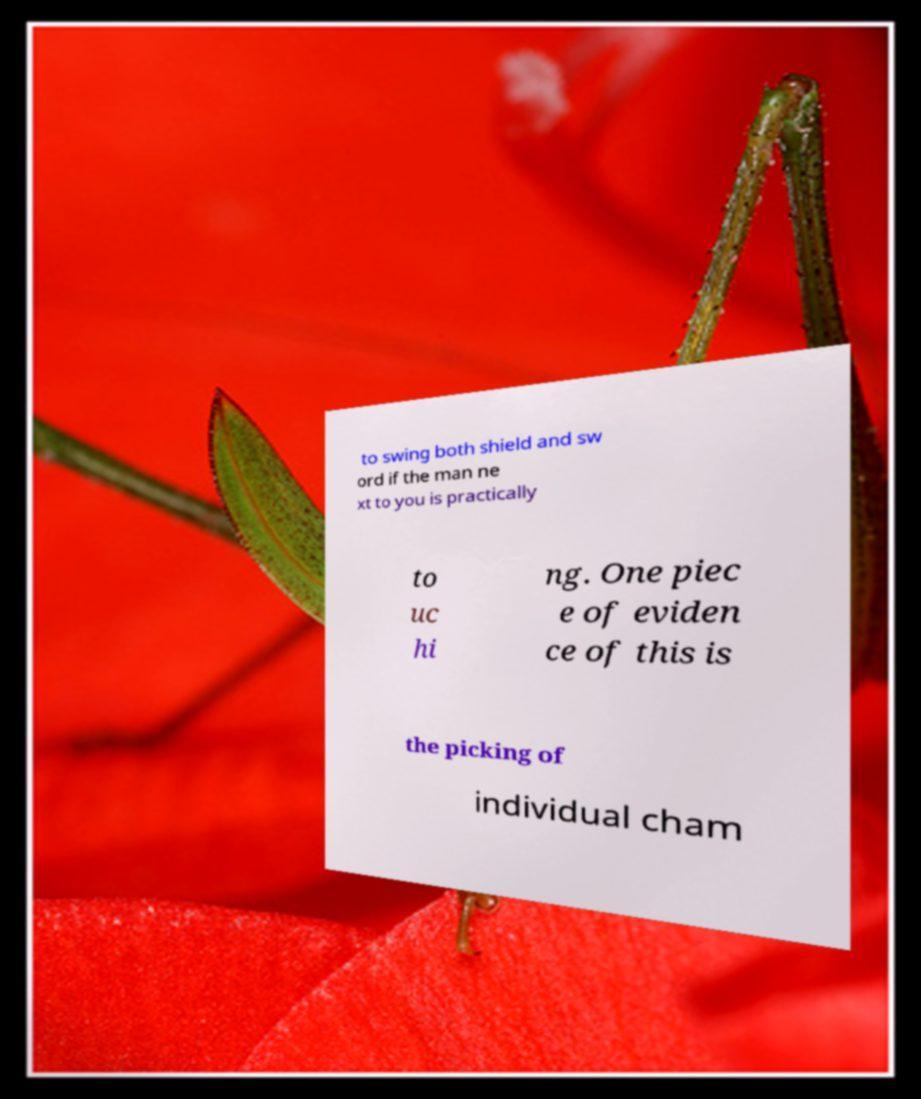What messages or text are displayed in this image? I need them in a readable, typed format. to swing both shield and sw ord if the man ne xt to you is practically to uc hi ng. One piec e of eviden ce of this is the picking of individual cham 